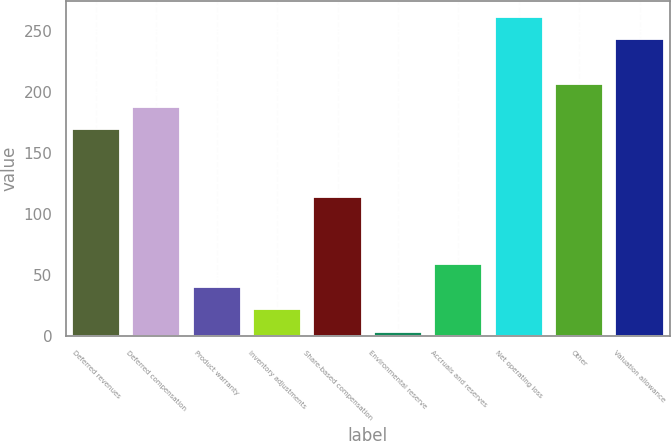Convert chart. <chart><loc_0><loc_0><loc_500><loc_500><bar_chart><fcel>Deferred revenues<fcel>Deferred compensation<fcel>Product warranty<fcel>Inventory adjustments<fcel>Share-based compensation<fcel>Environmental reserve<fcel>Accruals and reserves<fcel>Net operating loss<fcel>Other<fcel>Valuation allowance<nl><fcel>169.38<fcel>187.8<fcel>40.44<fcel>22.02<fcel>114.12<fcel>3.6<fcel>58.86<fcel>261.48<fcel>206.22<fcel>243.06<nl></chart> 